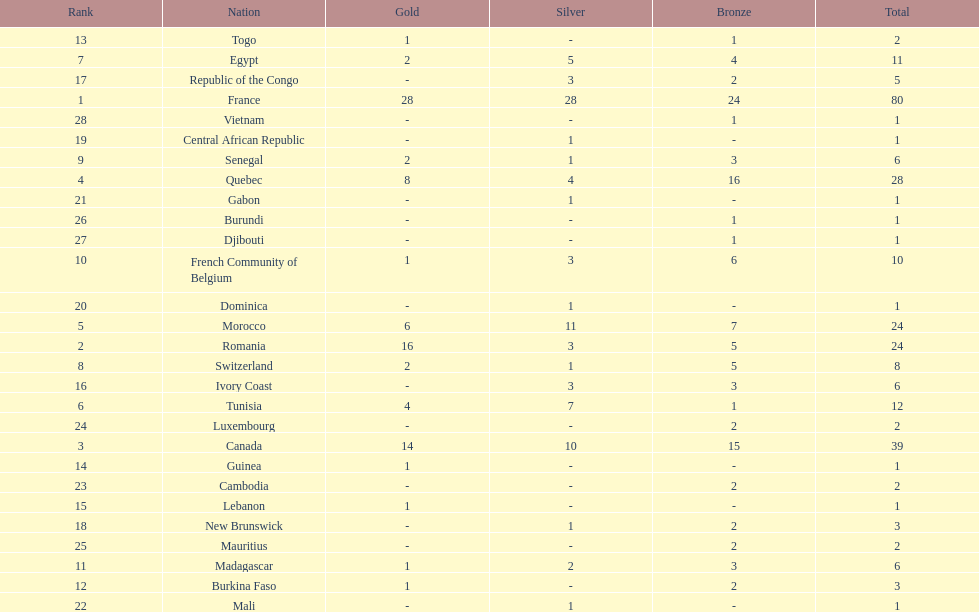What is the difference between france's and egypt's silver medals? 23. 